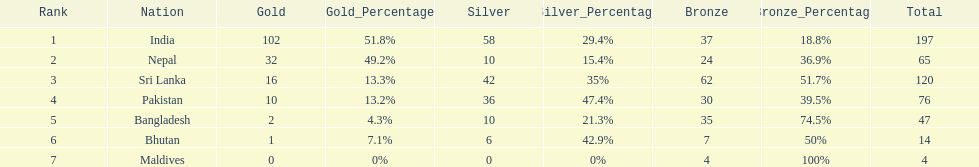How many more gold medals has nepal won than pakistan? 22. 